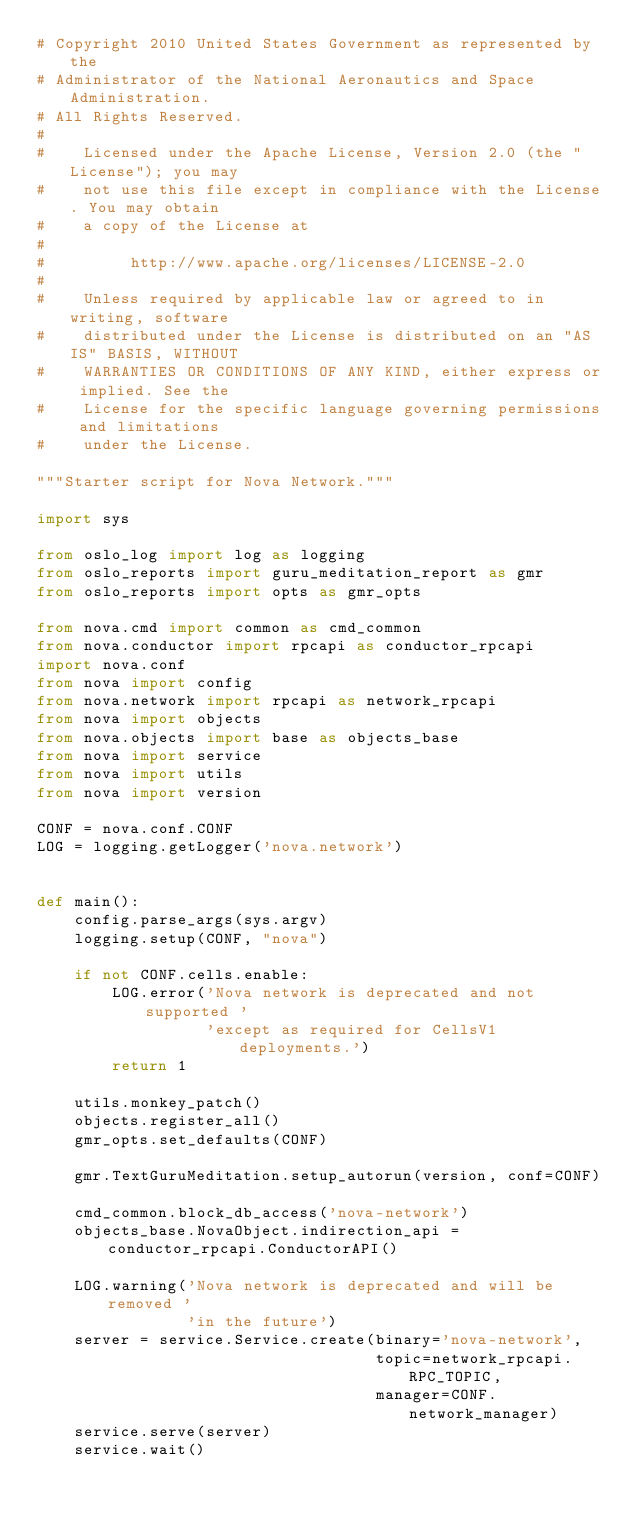<code> <loc_0><loc_0><loc_500><loc_500><_Python_># Copyright 2010 United States Government as represented by the
# Administrator of the National Aeronautics and Space Administration.
# All Rights Reserved.
#
#    Licensed under the Apache License, Version 2.0 (the "License"); you may
#    not use this file except in compliance with the License. You may obtain
#    a copy of the License at
#
#         http://www.apache.org/licenses/LICENSE-2.0
#
#    Unless required by applicable law or agreed to in writing, software
#    distributed under the License is distributed on an "AS IS" BASIS, WITHOUT
#    WARRANTIES OR CONDITIONS OF ANY KIND, either express or implied. See the
#    License for the specific language governing permissions and limitations
#    under the License.

"""Starter script for Nova Network."""

import sys

from oslo_log import log as logging
from oslo_reports import guru_meditation_report as gmr
from oslo_reports import opts as gmr_opts

from nova.cmd import common as cmd_common
from nova.conductor import rpcapi as conductor_rpcapi
import nova.conf
from nova import config
from nova.network import rpcapi as network_rpcapi
from nova import objects
from nova.objects import base as objects_base
from nova import service
from nova import utils
from nova import version

CONF = nova.conf.CONF
LOG = logging.getLogger('nova.network')


def main():
    config.parse_args(sys.argv)
    logging.setup(CONF, "nova")

    if not CONF.cells.enable:
        LOG.error('Nova network is deprecated and not supported '
                  'except as required for CellsV1 deployments.')
        return 1

    utils.monkey_patch()
    objects.register_all()
    gmr_opts.set_defaults(CONF)

    gmr.TextGuruMeditation.setup_autorun(version, conf=CONF)

    cmd_common.block_db_access('nova-network')
    objects_base.NovaObject.indirection_api = conductor_rpcapi.ConductorAPI()

    LOG.warning('Nova network is deprecated and will be removed '
                'in the future')
    server = service.Service.create(binary='nova-network',
                                    topic=network_rpcapi.RPC_TOPIC,
                                    manager=CONF.network_manager)
    service.serve(server)
    service.wait()
</code> 